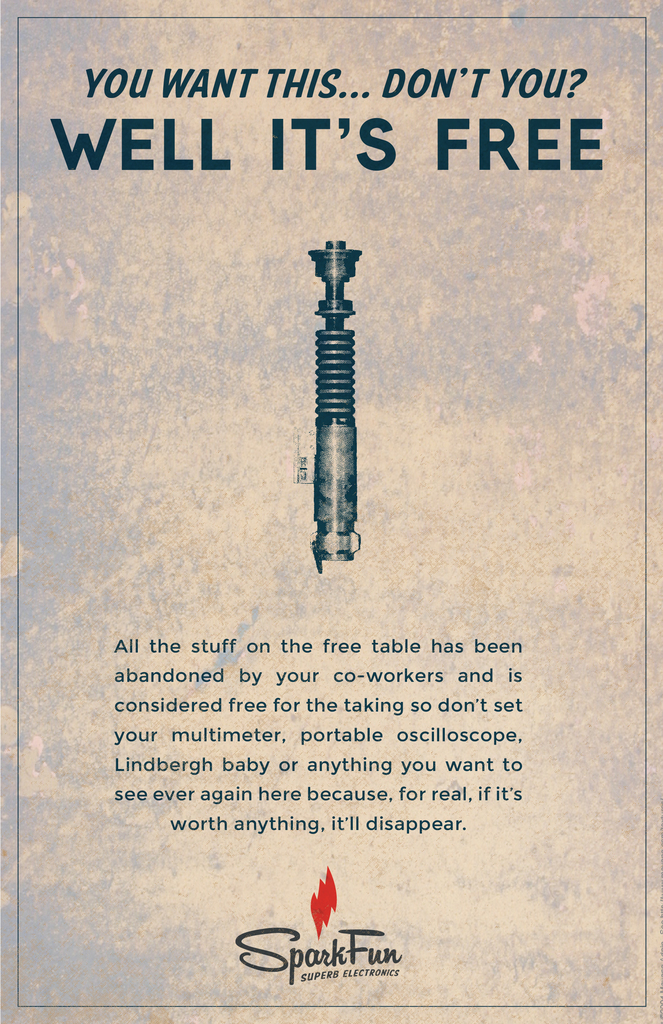What are the key elements in this picture? The image prominently features an advertisement by SparkFun Electronics. It showcases a soldering iron with commanding text above, 'You want this... don't you? Well, it's free', enticing the viewer with an offer of a free item. The text below gives context that this soldering iron is part of a 'free wall' where items left by coworkers are available for taking, promoting a culture of reuse and sharing at SparkFun. The ad cleverly employs a mix of bold typography and a stark image of the soldering iron to attract attention, reflecting effective marketing tactics designed to directly engage and intrigue the viewer. 